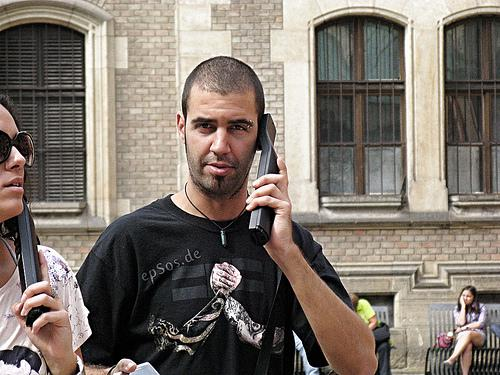Question: what is in the background?
Choices:
A. A flag.
B. The house.
C. A brick building.
D. Trees.
Answer with the letter. Answer: C Question: what does the man have in his hand?
Choices:
A. Hat.
B. Cane.
C. Book.
D. A cell phone.
Answer with the letter. Answer: D 